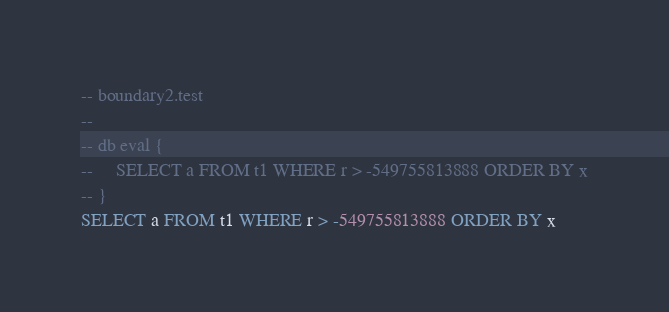<code> <loc_0><loc_0><loc_500><loc_500><_SQL_>-- boundary2.test
-- 
-- db eval {
--     SELECT a FROM t1 WHERE r > -549755813888 ORDER BY x
-- }
SELECT a FROM t1 WHERE r > -549755813888 ORDER BY x</code> 